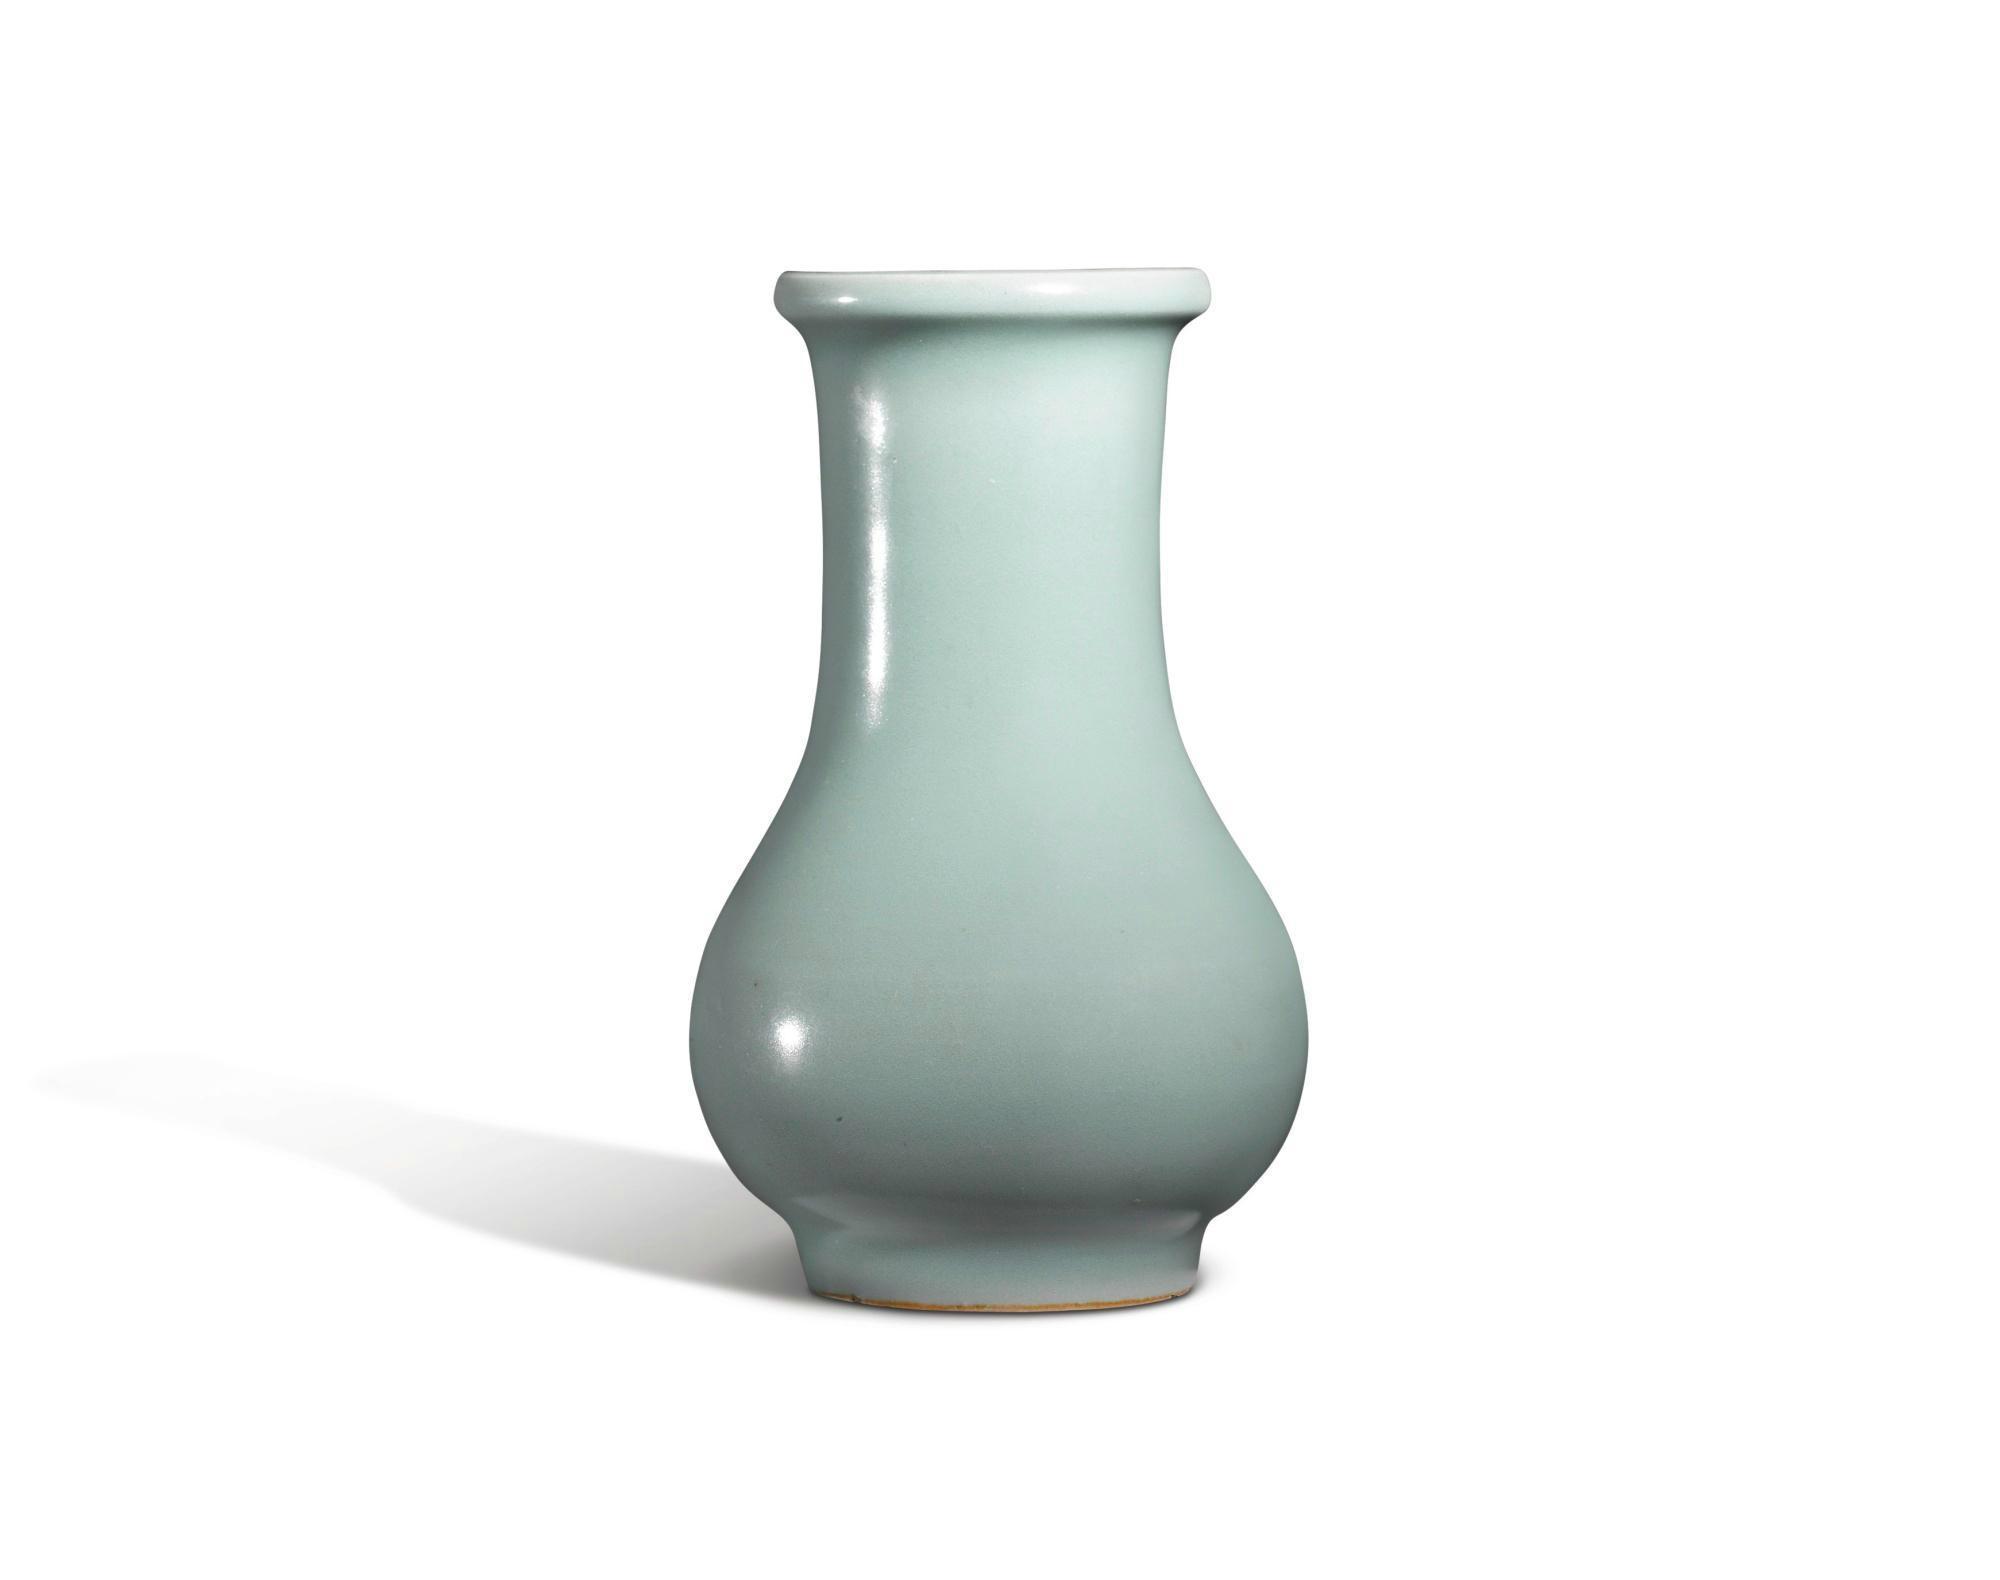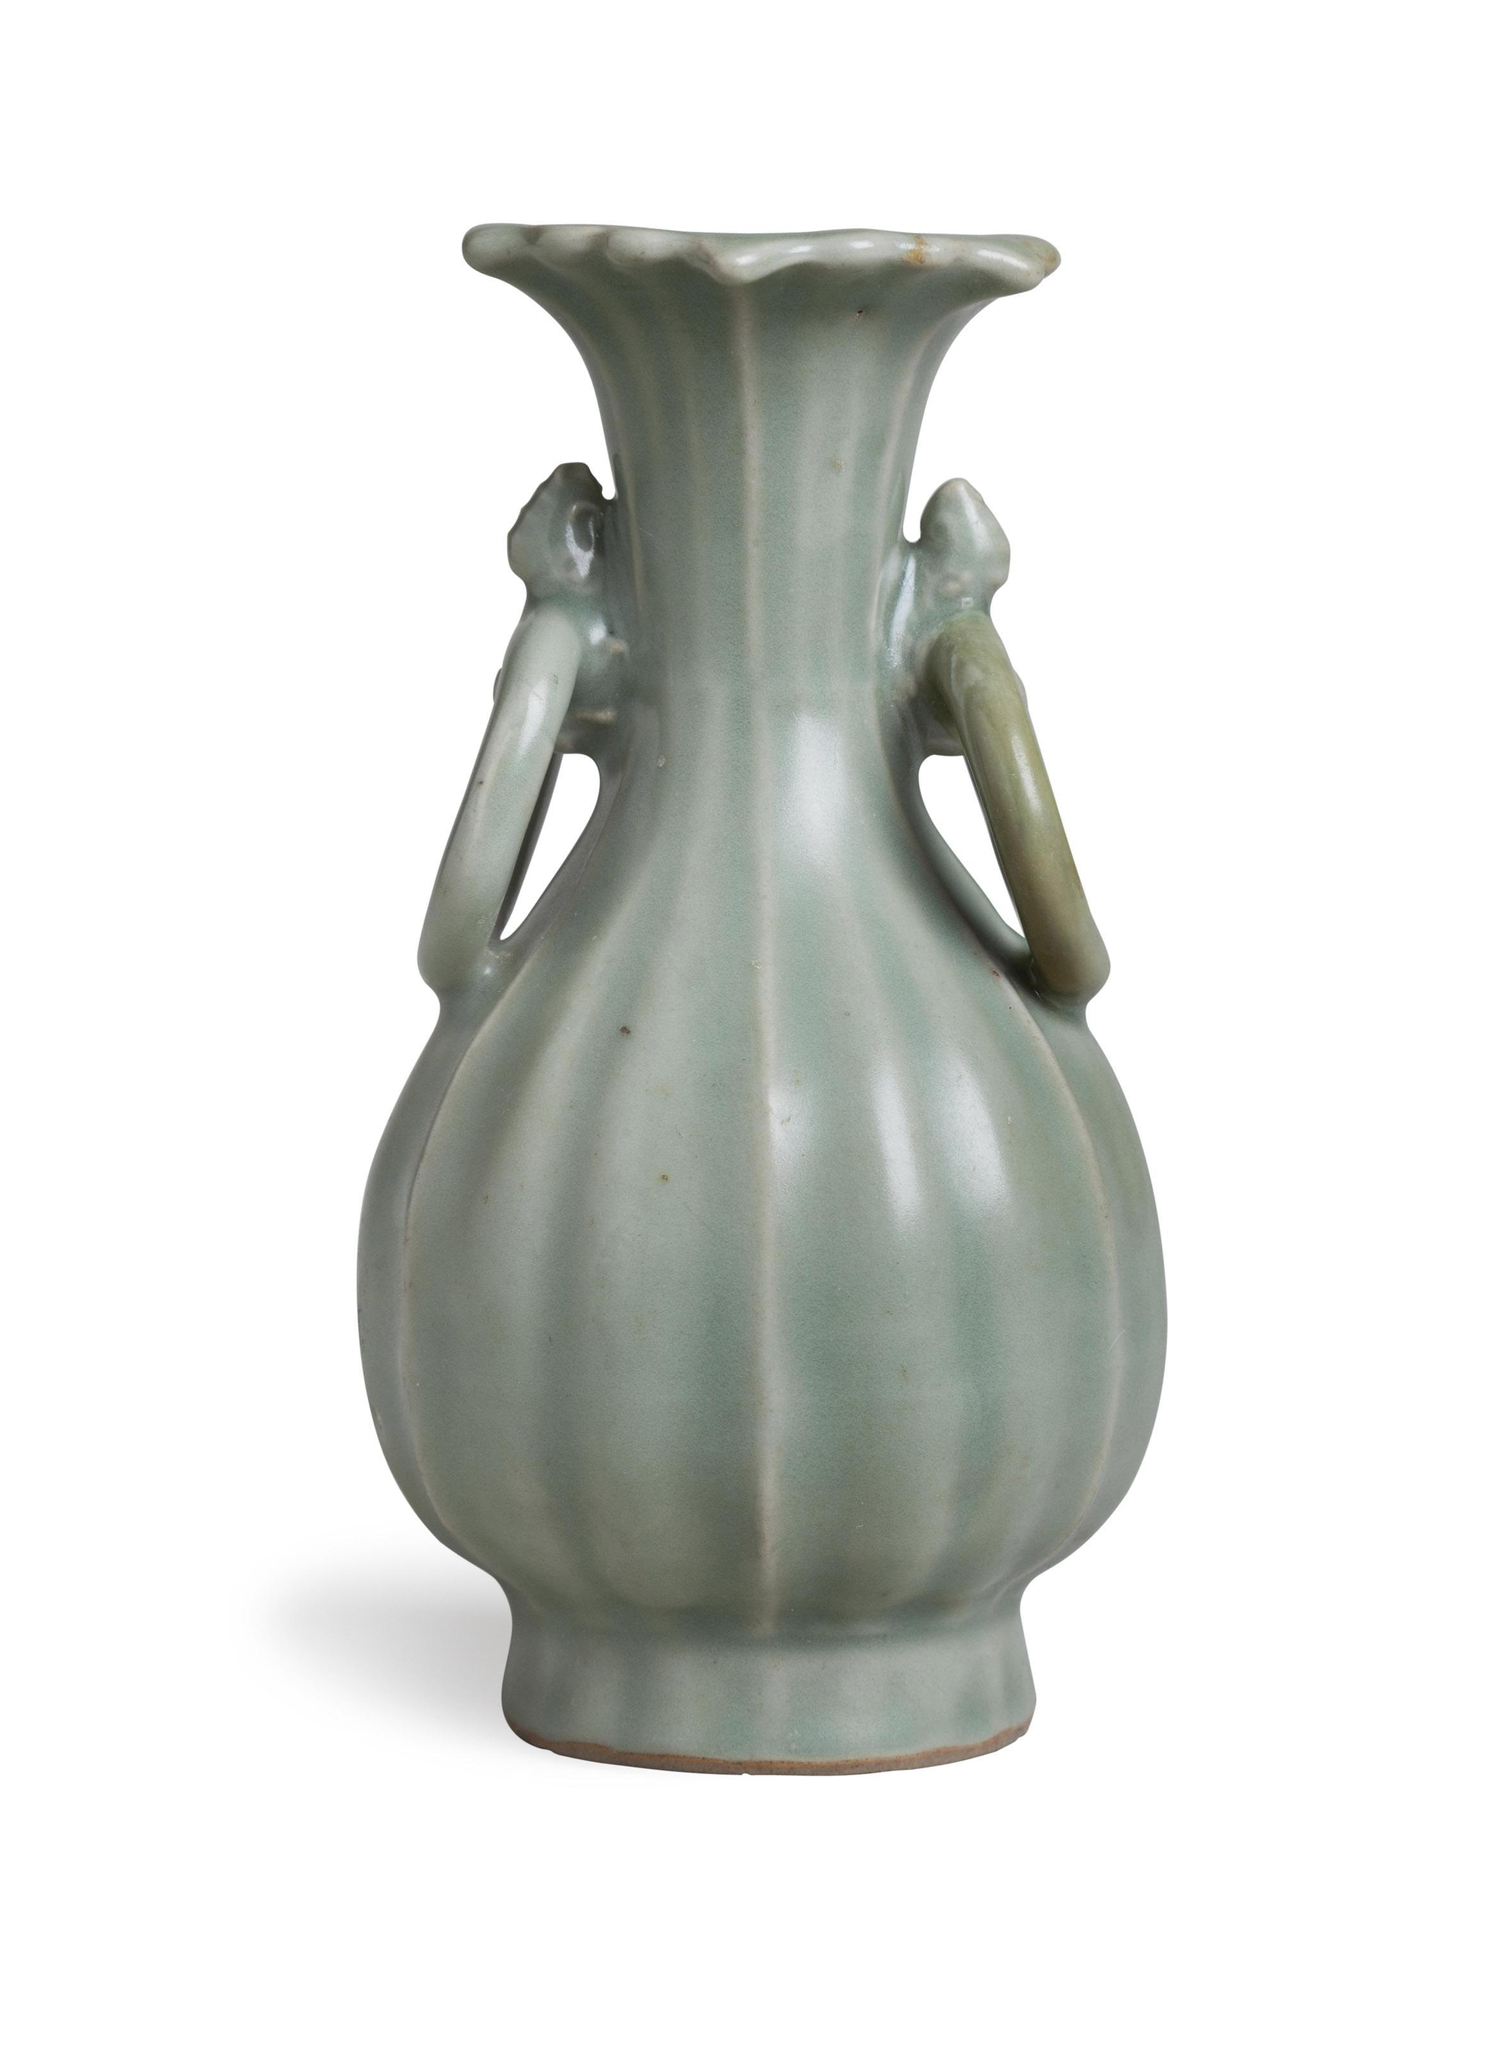The first image is the image on the left, the second image is the image on the right. For the images shown, is this caption "One of the vases has slender handles on each side, a dimensional ribbed element, and a fluted top." true? Answer yes or no. Yes. The first image is the image on the left, the second image is the image on the right. Assess this claim about the two images: "An image contains a green vase that has two handles around its neck.". Correct or not? Answer yes or no. Yes. 